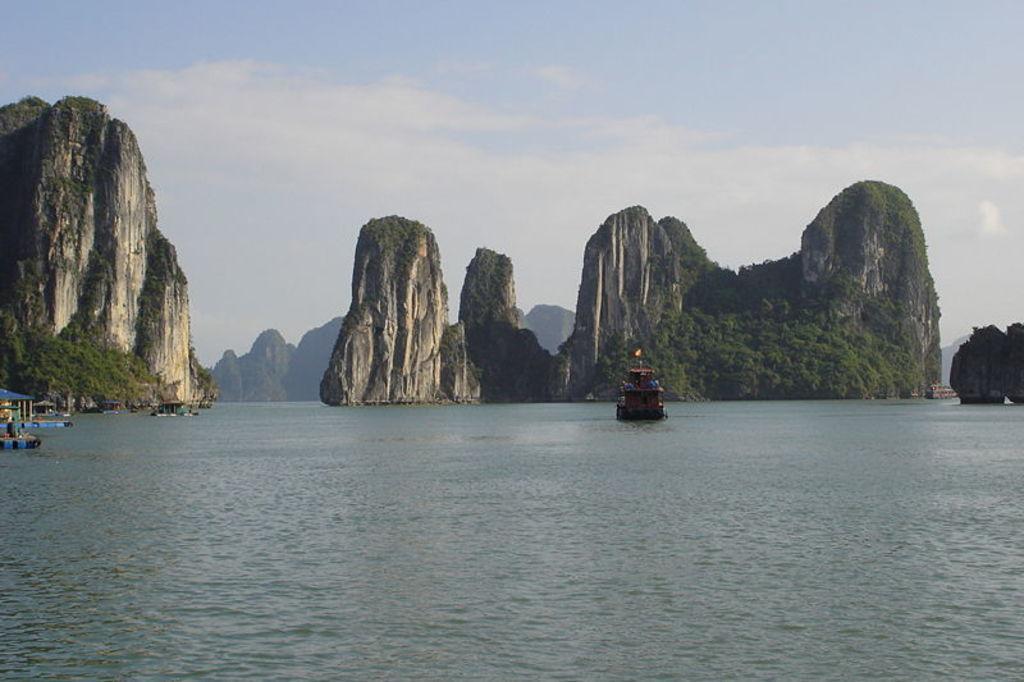Describe this image in one or two sentences. In this image I can see water and in it I can see few boats. In the background I can see few more boats over there and I can also see the sky. 